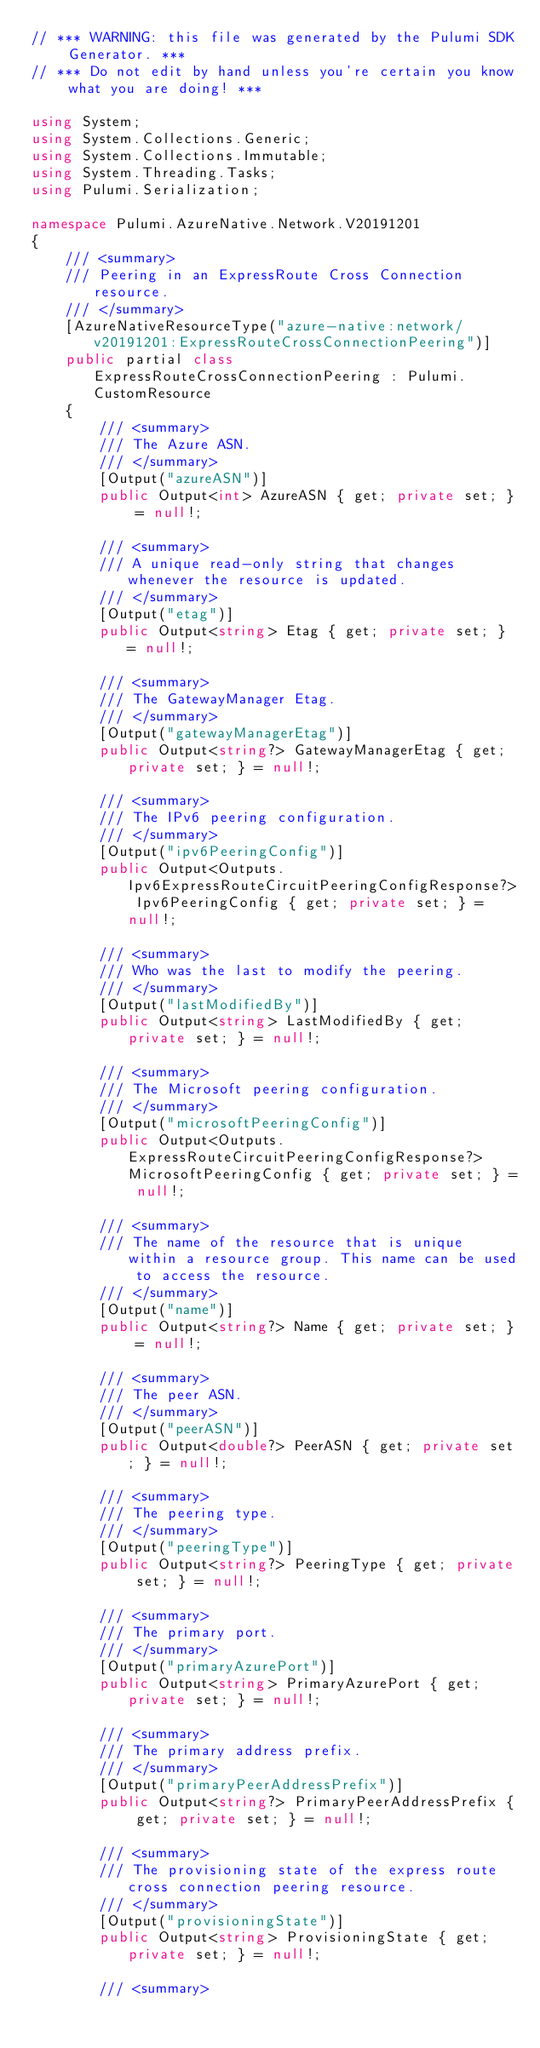<code> <loc_0><loc_0><loc_500><loc_500><_C#_>// *** WARNING: this file was generated by the Pulumi SDK Generator. ***
// *** Do not edit by hand unless you're certain you know what you are doing! ***

using System;
using System.Collections.Generic;
using System.Collections.Immutable;
using System.Threading.Tasks;
using Pulumi.Serialization;

namespace Pulumi.AzureNative.Network.V20191201
{
    /// <summary>
    /// Peering in an ExpressRoute Cross Connection resource.
    /// </summary>
    [AzureNativeResourceType("azure-native:network/v20191201:ExpressRouteCrossConnectionPeering")]
    public partial class ExpressRouteCrossConnectionPeering : Pulumi.CustomResource
    {
        /// <summary>
        /// The Azure ASN.
        /// </summary>
        [Output("azureASN")]
        public Output<int> AzureASN { get; private set; } = null!;

        /// <summary>
        /// A unique read-only string that changes whenever the resource is updated.
        /// </summary>
        [Output("etag")]
        public Output<string> Etag { get; private set; } = null!;

        /// <summary>
        /// The GatewayManager Etag.
        /// </summary>
        [Output("gatewayManagerEtag")]
        public Output<string?> GatewayManagerEtag { get; private set; } = null!;

        /// <summary>
        /// The IPv6 peering configuration.
        /// </summary>
        [Output("ipv6PeeringConfig")]
        public Output<Outputs.Ipv6ExpressRouteCircuitPeeringConfigResponse?> Ipv6PeeringConfig { get; private set; } = null!;

        /// <summary>
        /// Who was the last to modify the peering.
        /// </summary>
        [Output("lastModifiedBy")]
        public Output<string> LastModifiedBy { get; private set; } = null!;

        /// <summary>
        /// The Microsoft peering configuration.
        /// </summary>
        [Output("microsoftPeeringConfig")]
        public Output<Outputs.ExpressRouteCircuitPeeringConfigResponse?> MicrosoftPeeringConfig { get; private set; } = null!;

        /// <summary>
        /// The name of the resource that is unique within a resource group. This name can be used to access the resource.
        /// </summary>
        [Output("name")]
        public Output<string?> Name { get; private set; } = null!;

        /// <summary>
        /// The peer ASN.
        /// </summary>
        [Output("peerASN")]
        public Output<double?> PeerASN { get; private set; } = null!;

        /// <summary>
        /// The peering type.
        /// </summary>
        [Output("peeringType")]
        public Output<string?> PeeringType { get; private set; } = null!;

        /// <summary>
        /// The primary port.
        /// </summary>
        [Output("primaryAzurePort")]
        public Output<string> PrimaryAzurePort { get; private set; } = null!;

        /// <summary>
        /// The primary address prefix.
        /// </summary>
        [Output("primaryPeerAddressPrefix")]
        public Output<string?> PrimaryPeerAddressPrefix { get; private set; } = null!;

        /// <summary>
        /// The provisioning state of the express route cross connection peering resource.
        /// </summary>
        [Output("provisioningState")]
        public Output<string> ProvisioningState { get; private set; } = null!;

        /// <summary></code> 